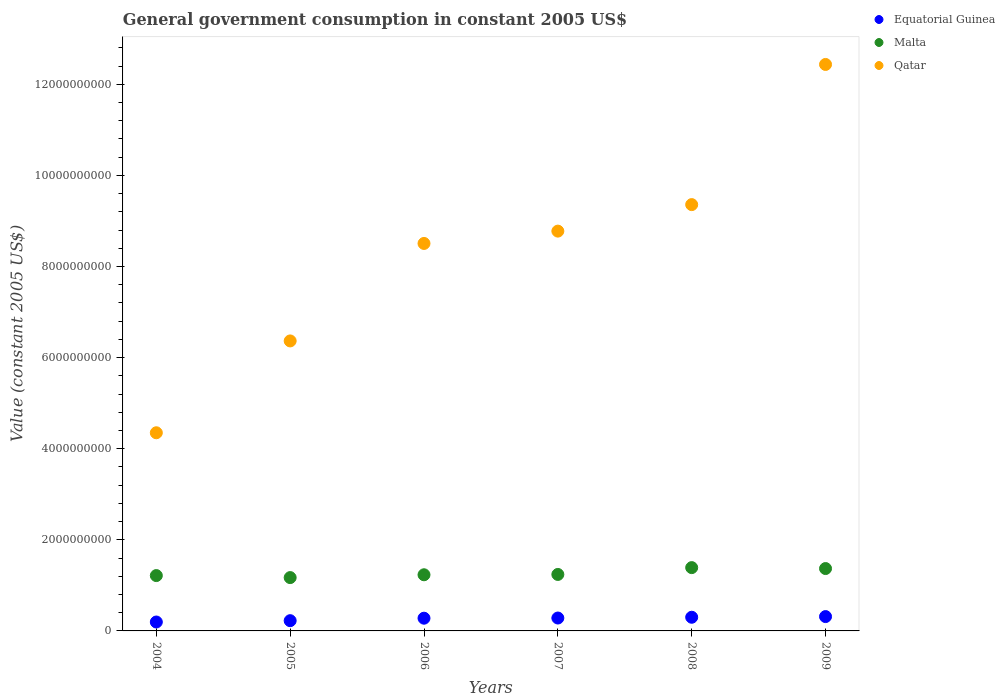How many different coloured dotlines are there?
Keep it short and to the point. 3. Is the number of dotlines equal to the number of legend labels?
Ensure brevity in your answer.  Yes. What is the government conusmption in Equatorial Guinea in 2006?
Ensure brevity in your answer.  2.79e+08. Across all years, what is the maximum government conusmption in Qatar?
Provide a short and direct response. 1.24e+1. Across all years, what is the minimum government conusmption in Qatar?
Give a very brief answer. 4.35e+09. In which year was the government conusmption in Qatar minimum?
Your answer should be compact. 2004. What is the total government conusmption in Equatorial Guinea in the graph?
Offer a terse response. 1.60e+09. What is the difference between the government conusmption in Equatorial Guinea in 2007 and that in 2009?
Your answer should be compact. -3.17e+07. What is the difference between the government conusmption in Equatorial Guinea in 2006 and the government conusmption in Qatar in 2005?
Your answer should be very brief. -6.09e+09. What is the average government conusmption in Qatar per year?
Your answer should be compact. 8.30e+09. In the year 2009, what is the difference between the government conusmption in Malta and government conusmption in Equatorial Guinea?
Ensure brevity in your answer.  1.05e+09. In how many years, is the government conusmption in Qatar greater than 2400000000 US$?
Your answer should be very brief. 6. What is the ratio of the government conusmption in Malta in 2004 to that in 2009?
Keep it short and to the point. 0.89. Is the government conusmption in Malta in 2005 less than that in 2009?
Provide a succinct answer. Yes. What is the difference between the highest and the second highest government conusmption in Equatorial Guinea?
Your answer should be very brief. 1.48e+07. What is the difference between the highest and the lowest government conusmption in Equatorial Guinea?
Your answer should be compact. 1.19e+08. In how many years, is the government conusmption in Equatorial Guinea greater than the average government conusmption in Equatorial Guinea taken over all years?
Ensure brevity in your answer.  4. Is the sum of the government conusmption in Equatorial Guinea in 2004 and 2006 greater than the maximum government conusmption in Qatar across all years?
Offer a very short reply. No. Is it the case that in every year, the sum of the government conusmption in Qatar and government conusmption in Equatorial Guinea  is greater than the government conusmption in Malta?
Provide a short and direct response. Yes. Does the government conusmption in Qatar monotonically increase over the years?
Offer a terse response. Yes. Is the government conusmption in Malta strictly greater than the government conusmption in Qatar over the years?
Give a very brief answer. No. How many years are there in the graph?
Provide a short and direct response. 6. Are the values on the major ticks of Y-axis written in scientific E-notation?
Your response must be concise. No. Does the graph contain grids?
Give a very brief answer. No. How many legend labels are there?
Offer a very short reply. 3. How are the legend labels stacked?
Offer a terse response. Vertical. What is the title of the graph?
Your answer should be very brief. General government consumption in constant 2005 US$. What is the label or title of the Y-axis?
Give a very brief answer. Value (constant 2005 US$). What is the Value (constant 2005 US$) of Equatorial Guinea in 2004?
Ensure brevity in your answer.  1.96e+08. What is the Value (constant 2005 US$) in Malta in 2004?
Give a very brief answer. 1.21e+09. What is the Value (constant 2005 US$) in Qatar in 2004?
Offer a terse response. 4.35e+09. What is the Value (constant 2005 US$) in Equatorial Guinea in 2005?
Ensure brevity in your answer.  2.25e+08. What is the Value (constant 2005 US$) of Malta in 2005?
Provide a succinct answer. 1.17e+09. What is the Value (constant 2005 US$) in Qatar in 2005?
Your answer should be very brief. 6.37e+09. What is the Value (constant 2005 US$) of Equatorial Guinea in 2006?
Ensure brevity in your answer.  2.79e+08. What is the Value (constant 2005 US$) in Malta in 2006?
Provide a succinct answer. 1.23e+09. What is the Value (constant 2005 US$) of Qatar in 2006?
Provide a short and direct response. 8.51e+09. What is the Value (constant 2005 US$) in Equatorial Guinea in 2007?
Offer a terse response. 2.83e+08. What is the Value (constant 2005 US$) of Malta in 2007?
Your answer should be very brief. 1.24e+09. What is the Value (constant 2005 US$) in Qatar in 2007?
Ensure brevity in your answer.  8.78e+09. What is the Value (constant 2005 US$) of Equatorial Guinea in 2008?
Your answer should be very brief. 3.00e+08. What is the Value (constant 2005 US$) in Malta in 2008?
Make the answer very short. 1.39e+09. What is the Value (constant 2005 US$) of Qatar in 2008?
Provide a succinct answer. 9.36e+09. What is the Value (constant 2005 US$) of Equatorial Guinea in 2009?
Give a very brief answer. 3.15e+08. What is the Value (constant 2005 US$) of Malta in 2009?
Your answer should be compact. 1.37e+09. What is the Value (constant 2005 US$) of Qatar in 2009?
Keep it short and to the point. 1.24e+1. Across all years, what is the maximum Value (constant 2005 US$) of Equatorial Guinea?
Keep it short and to the point. 3.15e+08. Across all years, what is the maximum Value (constant 2005 US$) in Malta?
Keep it short and to the point. 1.39e+09. Across all years, what is the maximum Value (constant 2005 US$) of Qatar?
Make the answer very short. 1.24e+1. Across all years, what is the minimum Value (constant 2005 US$) in Equatorial Guinea?
Offer a terse response. 1.96e+08. Across all years, what is the minimum Value (constant 2005 US$) of Malta?
Make the answer very short. 1.17e+09. Across all years, what is the minimum Value (constant 2005 US$) in Qatar?
Your answer should be compact. 4.35e+09. What is the total Value (constant 2005 US$) of Equatorial Guinea in the graph?
Keep it short and to the point. 1.60e+09. What is the total Value (constant 2005 US$) in Malta in the graph?
Offer a terse response. 7.62e+09. What is the total Value (constant 2005 US$) in Qatar in the graph?
Your answer should be compact. 4.98e+1. What is the difference between the Value (constant 2005 US$) in Equatorial Guinea in 2004 and that in 2005?
Ensure brevity in your answer.  -2.92e+07. What is the difference between the Value (constant 2005 US$) of Malta in 2004 and that in 2005?
Your answer should be very brief. 4.41e+07. What is the difference between the Value (constant 2005 US$) in Qatar in 2004 and that in 2005?
Ensure brevity in your answer.  -2.02e+09. What is the difference between the Value (constant 2005 US$) in Equatorial Guinea in 2004 and that in 2006?
Give a very brief answer. -8.36e+07. What is the difference between the Value (constant 2005 US$) in Malta in 2004 and that in 2006?
Ensure brevity in your answer.  -1.77e+07. What is the difference between the Value (constant 2005 US$) in Qatar in 2004 and that in 2006?
Make the answer very short. -4.16e+09. What is the difference between the Value (constant 2005 US$) in Equatorial Guinea in 2004 and that in 2007?
Offer a terse response. -8.74e+07. What is the difference between the Value (constant 2005 US$) in Malta in 2004 and that in 2007?
Provide a succinct answer. -2.49e+07. What is the difference between the Value (constant 2005 US$) in Qatar in 2004 and that in 2007?
Your answer should be compact. -4.43e+09. What is the difference between the Value (constant 2005 US$) in Equatorial Guinea in 2004 and that in 2008?
Your response must be concise. -1.04e+08. What is the difference between the Value (constant 2005 US$) of Malta in 2004 and that in 2008?
Offer a terse response. -1.75e+08. What is the difference between the Value (constant 2005 US$) of Qatar in 2004 and that in 2008?
Your response must be concise. -5.01e+09. What is the difference between the Value (constant 2005 US$) of Equatorial Guinea in 2004 and that in 2009?
Ensure brevity in your answer.  -1.19e+08. What is the difference between the Value (constant 2005 US$) in Malta in 2004 and that in 2009?
Ensure brevity in your answer.  -1.54e+08. What is the difference between the Value (constant 2005 US$) of Qatar in 2004 and that in 2009?
Your response must be concise. -8.09e+09. What is the difference between the Value (constant 2005 US$) of Equatorial Guinea in 2005 and that in 2006?
Ensure brevity in your answer.  -5.44e+07. What is the difference between the Value (constant 2005 US$) in Malta in 2005 and that in 2006?
Give a very brief answer. -6.18e+07. What is the difference between the Value (constant 2005 US$) in Qatar in 2005 and that in 2006?
Your answer should be compact. -2.14e+09. What is the difference between the Value (constant 2005 US$) of Equatorial Guinea in 2005 and that in 2007?
Make the answer very short. -5.83e+07. What is the difference between the Value (constant 2005 US$) of Malta in 2005 and that in 2007?
Keep it short and to the point. -6.90e+07. What is the difference between the Value (constant 2005 US$) of Qatar in 2005 and that in 2007?
Keep it short and to the point. -2.41e+09. What is the difference between the Value (constant 2005 US$) in Equatorial Guinea in 2005 and that in 2008?
Give a very brief answer. -7.52e+07. What is the difference between the Value (constant 2005 US$) in Malta in 2005 and that in 2008?
Make the answer very short. -2.19e+08. What is the difference between the Value (constant 2005 US$) of Qatar in 2005 and that in 2008?
Keep it short and to the point. -2.99e+09. What is the difference between the Value (constant 2005 US$) in Equatorial Guinea in 2005 and that in 2009?
Give a very brief answer. -9.00e+07. What is the difference between the Value (constant 2005 US$) in Malta in 2005 and that in 2009?
Your response must be concise. -1.98e+08. What is the difference between the Value (constant 2005 US$) in Qatar in 2005 and that in 2009?
Offer a terse response. -6.07e+09. What is the difference between the Value (constant 2005 US$) of Equatorial Guinea in 2006 and that in 2007?
Keep it short and to the point. -3.85e+06. What is the difference between the Value (constant 2005 US$) in Malta in 2006 and that in 2007?
Give a very brief answer. -7.18e+06. What is the difference between the Value (constant 2005 US$) in Qatar in 2006 and that in 2007?
Provide a short and direct response. -2.71e+08. What is the difference between the Value (constant 2005 US$) of Equatorial Guinea in 2006 and that in 2008?
Provide a short and direct response. -2.08e+07. What is the difference between the Value (constant 2005 US$) in Malta in 2006 and that in 2008?
Your answer should be compact. -1.57e+08. What is the difference between the Value (constant 2005 US$) of Qatar in 2006 and that in 2008?
Make the answer very short. -8.52e+08. What is the difference between the Value (constant 2005 US$) in Equatorial Guinea in 2006 and that in 2009?
Ensure brevity in your answer.  -3.56e+07. What is the difference between the Value (constant 2005 US$) in Malta in 2006 and that in 2009?
Offer a terse response. -1.37e+08. What is the difference between the Value (constant 2005 US$) of Qatar in 2006 and that in 2009?
Offer a terse response. -3.93e+09. What is the difference between the Value (constant 2005 US$) in Equatorial Guinea in 2007 and that in 2008?
Ensure brevity in your answer.  -1.69e+07. What is the difference between the Value (constant 2005 US$) in Malta in 2007 and that in 2008?
Your response must be concise. -1.50e+08. What is the difference between the Value (constant 2005 US$) of Qatar in 2007 and that in 2008?
Your answer should be very brief. -5.82e+08. What is the difference between the Value (constant 2005 US$) of Equatorial Guinea in 2007 and that in 2009?
Your answer should be very brief. -3.17e+07. What is the difference between the Value (constant 2005 US$) of Malta in 2007 and that in 2009?
Make the answer very short. -1.29e+08. What is the difference between the Value (constant 2005 US$) of Qatar in 2007 and that in 2009?
Ensure brevity in your answer.  -3.66e+09. What is the difference between the Value (constant 2005 US$) of Equatorial Guinea in 2008 and that in 2009?
Your answer should be very brief. -1.48e+07. What is the difference between the Value (constant 2005 US$) in Malta in 2008 and that in 2009?
Keep it short and to the point. 2.03e+07. What is the difference between the Value (constant 2005 US$) in Qatar in 2008 and that in 2009?
Make the answer very short. -3.08e+09. What is the difference between the Value (constant 2005 US$) in Equatorial Guinea in 2004 and the Value (constant 2005 US$) in Malta in 2005?
Your answer should be compact. -9.75e+08. What is the difference between the Value (constant 2005 US$) of Equatorial Guinea in 2004 and the Value (constant 2005 US$) of Qatar in 2005?
Your response must be concise. -6.17e+09. What is the difference between the Value (constant 2005 US$) in Malta in 2004 and the Value (constant 2005 US$) in Qatar in 2005?
Keep it short and to the point. -5.15e+09. What is the difference between the Value (constant 2005 US$) of Equatorial Guinea in 2004 and the Value (constant 2005 US$) of Malta in 2006?
Provide a succinct answer. -1.04e+09. What is the difference between the Value (constant 2005 US$) in Equatorial Guinea in 2004 and the Value (constant 2005 US$) in Qatar in 2006?
Keep it short and to the point. -8.31e+09. What is the difference between the Value (constant 2005 US$) in Malta in 2004 and the Value (constant 2005 US$) in Qatar in 2006?
Your answer should be very brief. -7.29e+09. What is the difference between the Value (constant 2005 US$) in Equatorial Guinea in 2004 and the Value (constant 2005 US$) in Malta in 2007?
Your response must be concise. -1.04e+09. What is the difference between the Value (constant 2005 US$) of Equatorial Guinea in 2004 and the Value (constant 2005 US$) of Qatar in 2007?
Your answer should be compact. -8.58e+09. What is the difference between the Value (constant 2005 US$) in Malta in 2004 and the Value (constant 2005 US$) in Qatar in 2007?
Provide a short and direct response. -7.56e+09. What is the difference between the Value (constant 2005 US$) in Equatorial Guinea in 2004 and the Value (constant 2005 US$) in Malta in 2008?
Provide a succinct answer. -1.19e+09. What is the difference between the Value (constant 2005 US$) in Equatorial Guinea in 2004 and the Value (constant 2005 US$) in Qatar in 2008?
Give a very brief answer. -9.16e+09. What is the difference between the Value (constant 2005 US$) of Malta in 2004 and the Value (constant 2005 US$) of Qatar in 2008?
Your answer should be very brief. -8.14e+09. What is the difference between the Value (constant 2005 US$) of Equatorial Guinea in 2004 and the Value (constant 2005 US$) of Malta in 2009?
Your answer should be very brief. -1.17e+09. What is the difference between the Value (constant 2005 US$) in Equatorial Guinea in 2004 and the Value (constant 2005 US$) in Qatar in 2009?
Provide a short and direct response. -1.22e+1. What is the difference between the Value (constant 2005 US$) of Malta in 2004 and the Value (constant 2005 US$) of Qatar in 2009?
Offer a terse response. -1.12e+1. What is the difference between the Value (constant 2005 US$) in Equatorial Guinea in 2005 and the Value (constant 2005 US$) in Malta in 2006?
Your answer should be very brief. -1.01e+09. What is the difference between the Value (constant 2005 US$) in Equatorial Guinea in 2005 and the Value (constant 2005 US$) in Qatar in 2006?
Make the answer very short. -8.28e+09. What is the difference between the Value (constant 2005 US$) in Malta in 2005 and the Value (constant 2005 US$) in Qatar in 2006?
Keep it short and to the point. -7.33e+09. What is the difference between the Value (constant 2005 US$) in Equatorial Guinea in 2005 and the Value (constant 2005 US$) in Malta in 2007?
Your answer should be very brief. -1.01e+09. What is the difference between the Value (constant 2005 US$) in Equatorial Guinea in 2005 and the Value (constant 2005 US$) in Qatar in 2007?
Offer a terse response. -8.55e+09. What is the difference between the Value (constant 2005 US$) in Malta in 2005 and the Value (constant 2005 US$) in Qatar in 2007?
Give a very brief answer. -7.61e+09. What is the difference between the Value (constant 2005 US$) in Equatorial Guinea in 2005 and the Value (constant 2005 US$) in Malta in 2008?
Offer a terse response. -1.16e+09. What is the difference between the Value (constant 2005 US$) in Equatorial Guinea in 2005 and the Value (constant 2005 US$) in Qatar in 2008?
Your answer should be compact. -9.13e+09. What is the difference between the Value (constant 2005 US$) in Malta in 2005 and the Value (constant 2005 US$) in Qatar in 2008?
Provide a short and direct response. -8.19e+09. What is the difference between the Value (constant 2005 US$) of Equatorial Guinea in 2005 and the Value (constant 2005 US$) of Malta in 2009?
Ensure brevity in your answer.  -1.14e+09. What is the difference between the Value (constant 2005 US$) in Equatorial Guinea in 2005 and the Value (constant 2005 US$) in Qatar in 2009?
Your answer should be compact. -1.22e+1. What is the difference between the Value (constant 2005 US$) of Malta in 2005 and the Value (constant 2005 US$) of Qatar in 2009?
Offer a very short reply. -1.13e+1. What is the difference between the Value (constant 2005 US$) in Equatorial Guinea in 2006 and the Value (constant 2005 US$) in Malta in 2007?
Provide a short and direct response. -9.60e+08. What is the difference between the Value (constant 2005 US$) of Equatorial Guinea in 2006 and the Value (constant 2005 US$) of Qatar in 2007?
Make the answer very short. -8.50e+09. What is the difference between the Value (constant 2005 US$) in Malta in 2006 and the Value (constant 2005 US$) in Qatar in 2007?
Your response must be concise. -7.54e+09. What is the difference between the Value (constant 2005 US$) in Equatorial Guinea in 2006 and the Value (constant 2005 US$) in Malta in 2008?
Keep it short and to the point. -1.11e+09. What is the difference between the Value (constant 2005 US$) of Equatorial Guinea in 2006 and the Value (constant 2005 US$) of Qatar in 2008?
Offer a terse response. -9.08e+09. What is the difference between the Value (constant 2005 US$) of Malta in 2006 and the Value (constant 2005 US$) of Qatar in 2008?
Provide a succinct answer. -8.13e+09. What is the difference between the Value (constant 2005 US$) of Equatorial Guinea in 2006 and the Value (constant 2005 US$) of Malta in 2009?
Make the answer very short. -1.09e+09. What is the difference between the Value (constant 2005 US$) of Equatorial Guinea in 2006 and the Value (constant 2005 US$) of Qatar in 2009?
Your response must be concise. -1.22e+1. What is the difference between the Value (constant 2005 US$) of Malta in 2006 and the Value (constant 2005 US$) of Qatar in 2009?
Give a very brief answer. -1.12e+1. What is the difference between the Value (constant 2005 US$) of Equatorial Guinea in 2007 and the Value (constant 2005 US$) of Malta in 2008?
Your answer should be compact. -1.11e+09. What is the difference between the Value (constant 2005 US$) of Equatorial Guinea in 2007 and the Value (constant 2005 US$) of Qatar in 2008?
Give a very brief answer. -9.08e+09. What is the difference between the Value (constant 2005 US$) in Malta in 2007 and the Value (constant 2005 US$) in Qatar in 2008?
Offer a very short reply. -8.12e+09. What is the difference between the Value (constant 2005 US$) in Equatorial Guinea in 2007 and the Value (constant 2005 US$) in Malta in 2009?
Offer a very short reply. -1.09e+09. What is the difference between the Value (constant 2005 US$) in Equatorial Guinea in 2007 and the Value (constant 2005 US$) in Qatar in 2009?
Your response must be concise. -1.22e+1. What is the difference between the Value (constant 2005 US$) of Malta in 2007 and the Value (constant 2005 US$) of Qatar in 2009?
Your answer should be compact. -1.12e+1. What is the difference between the Value (constant 2005 US$) in Equatorial Guinea in 2008 and the Value (constant 2005 US$) in Malta in 2009?
Your answer should be compact. -1.07e+09. What is the difference between the Value (constant 2005 US$) of Equatorial Guinea in 2008 and the Value (constant 2005 US$) of Qatar in 2009?
Provide a succinct answer. -1.21e+1. What is the difference between the Value (constant 2005 US$) of Malta in 2008 and the Value (constant 2005 US$) of Qatar in 2009?
Make the answer very short. -1.10e+1. What is the average Value (constant 2005 US$) of Equatorial Guinea per year?
Ensure brevity in your answer.  2.66e+08. What is the average Value (constant 2005 US$) in Malta per year?
Provide a short and direct response. 1.27e+09. What is the average Value (constant 2005 US$) of Qatar per year?
Keep it short and to the point. 8.30e+09. In the year 2004, what is the difference between the Value (constant 2005 US$) in Equatorial Guinea and Value (constant 2005 US$) in Malta?
Ensure brevity in your answer.  -1.02e+09. In the year 2004, what is the difference between the Value (constant 2005 US$) in Equatorial Guinea and Value (constant 2005 US$) in Qatar?
Ensure brevity in your answer.  -4.15e+09. In the year 2004, what is the difference between the Value (constant 2005 US$) in Malta and Value (constant 2005 US$) in Qatar?
Ensure brevity in your answer.  -3.13e+09. In the year 2005, what is the difference between the Value (constant 2005 US$) in Equatorial Guinea and Value (constant 2005 US$) in Malta?
Keep it short and to the point. -9.46e+08. In the year 2005, what is the difference between the Value (constant 2005 US$) of Equatorial Guinea and Value (constant 2005 US$) of Qatar?
Provide a succinct answer. -6.14e+09. In the year 2005, what is the difference between the Value (constant 2005 US$) in Malta and Value (constant 2005 US$) in Qatar?
Your answer should be very brief. -5.20e+09. In the year 2006, what is the difference between the Value (constant 2005 US$) in Equatorial Guinea and Value (constant 2005 US$) in Malta?
Make the answer very short. -9.53e+08. In the year 2006, what is the difference between the Value (constant 2005 US$) in Equatorial Guinea and Value (constant 2005 US$) in Qatar?
Offer a terse response. -8.23e+09. In the year 2006, what is the difference between the Value (constant 2005 US$) of Malta and Value (constant 2005 US$) of Qatar?
Provide a succinct answer. -7.27e+09. In the year 2007, what is the difference between the Value (constant 2005 US$) in Equatorial Guinea and Value (constant 2005 US$) in Malta?
Your answer should be compact. -9.57e+08. In the year 2007, what is the difference between the Value (constant 2005 US$) of Equatorial Guinea and Value (constant 2005 US$) of Qatar?
Your response must be concise. -8.49e+09. In the year 2007, what is the difference between the Value (constant 2005 US$) in Malta and Value (constant 2005 US$) in Qatar?
Your response must be concise. -7.54e+09. In the year 2008, what is the difference between the Value (constant 2005 US$) of Equatorial Guinea and Value (constant 2005 US$) of Malta?
Your answer should be compact. -1.09e+09. In the year 2008, what is the difference between the Value (constant 2005 US$) of Equatorial Guinea and Value (constant 2005 US$) of Qatar?
Provide a succinct answer. -9.06e+09. In the year 2008, what is the difference between the Value (constant 2005 US$) in Malta and Value (constant 2005 US$) in Qatar?
Offer a very short reply. -7.97e+09. In the year 2009, what is the difference between the Value (constant 2005 US$) of Equatorial Guinea and Value (constant 2005 US$) of Malta?
Offer a very short reply. -1.05e+09. In the year 2009, what is the difference between the Value (constant 2005 US$) of Equatorial Guinea and Value (constant 2005 US$) of Qatar?
Offer a very short reply. -1.21e+1. In the year 2009, what is the difference between the Value (constant 2005 US$) of Malta and Value (constant 2005 US$) of Qatar?
Your answer should be very brief. -1.11e+1. What is the ratio of the Value (constant 2005 US$) in Equatorial Guinea in 2004 to that in 2005?
Your answer should be compact. 0.87. What is the ratio of the Value (constant 2005 US$) of Malta in 2004 to that in 2005?
Ensure brevity in your answer.  1.04. What is the ratio of the Value (constant 2005 US$) of Qatar in 2004 to that in 2005?
Your response must be concise. 0.68. What is the ratio of the Value (constant 2005 US$) in Equatorial Guinea in 2004 to that in 2006?
Ensure brevity in your answer.  0.7. What is the ratio of the Value (constant 2005 US$) of Malta in 2004 to that in 2006?
Your answer should be very brief. 0.99. What is the ratio of the Value (constant 2005 US$) in Qatar in 2004 to that in 2006?
Offer a terse response. 0.51. What is the ratio of the Value (constant 2005 US$) in Equatorial Guinea in 2004 to that in 2007?
Provide a short and direct response. 0.69. What is the ratio of the Value (constant 2005 US$) in Malta in 2004 to that in 2007?
Give a very brief answer. 0.98. What is the ratio of the Value (constant 2005 US$) in Qatar in 2004 to that in 2007?
Provide a short and direct response. 0.5. What is the ratio of the Value (constant 2005 US$) of Equatorial Guinea in 2004 to that in 2008?
Your answer should be very brief. 0.65. What is the ratio of the Value (constant 2005 US$) in Malta in 2004 to that in 2008?
Your response must be concise. 0.87. What is the ratio of the Value (constant 2005 US$) of Qatar in 2004 to that in 2008?
Your response must be concise. 0.46. What is the ratio of the Value (constant 2005 US$) in Equatorial Guinea in 2004 to that in 2009?
Provide a succinct answer. 0.62. What is the ratio of the Value (constant 2005 US$) of Malta in 2004 to that in 2009?
Make the answer very short. 0.89. What is the ratio of the Value (constant 2005 US$) in Qatar in 2004 to that in 2009?
Your answer should be very brief. 0.35. What is the ratio of the Value (constant 2005 US$) in Equatorial Guinea in 2005 to that in 2006?
Give a very brief answer. 0.81. What is the ratio of the Value (constant 2005 US$) of Malta in 2005 to that in 2006?
Make the answer very short. 0.95. What is the ratio of the Value (constant 2005 US$) in Qatar in 2005 to that in 2006?
Give a very brief answer. 0.75. What is the ratio of the Value (constant 2005 US$) of Equatorial Guinea in 2005 to that in 2007?
Your response must be concise. 0.79. What is the ratio of the Value (constant 2005 US$) in Malta in 2005 to that in 2007?
Make the answer very short. 0.94. What is the ratio of the Value (constant 2005 US$) of Qatar in 2005 to that in 2007?
Your response must be concise. 0.73. What is the ratio of the Value (constant 2005 US$) of Equatorial Guinea in 2005 to that in 2008?
Your answer should be compact. 0.75. What is the ratio of the Value (constant 2005 US$) in Malta in 2005 to that in 2008?
Provide a succinct answer. 0.84. What is the ratio of the Value (constant 2005 US$) in Qatar in 2005 to that in 2008?
Ensure brevity in your answer.  0.68. What is the ratio of the Value (constant 2005 US$) of Equatorial Guinea in 2005 to that in 2009?
Ensure brevity in your answer.  0.71. What is the ratio of the Value (constant 2005 US$) in Malta in 2005 to that in 2009?
Your response must be concise. 0.85. What is the ratio of the Value (constant 2005 US$) of Qatar in 2005 to that in 2009?
Provide a succinct answer. 0.51. What is the ratio of the Value (constant 2005 US$) in Equatorial Guinea in 2006 to that in 2007?
Keep it short and to the point. 0.99. What is the ratio of the Value (constant 2005 US$) of Malta in 2006 to that in 2007?
Offer a terse response. 0.99. What is the ratio of the Value (constant 2005 US$) in Qatar in 2006 to that in 2007?
Your response must be concise. 0.97. What is the ratio of the Value (constant 2005 US$) of Equatorial Guinea in 2006 to that in 2008?
Keep it short and to the point. 0.93. What is the ratio of the Value (constant 2005 US$) in Malta in 2006 to that in 2008?
Provide a short and direct response. 0.89. What is the ratio of the Value (constant 2005 US$) of Qatar in 2006 to that in 2008?
Give a very brief answer. 0.91. What is the ratio of the Value (constant 2005 US$) in Equatorial Guinea in 2006 to that in 2009?
Your response must be concise. 0.89. What is the ratio of the Value (constant 2005 US$) of Malta in 2006 to that in 2009?
Provide a short and direct response. 0.9. What is the ratio of the Value (constant 2005 US$) in Qatar in 2006 to that in 2009?
Keep it short and to the point. 0.68. What is the ratio of the Value (constant 2005 US$) of Equatorial Guinea in 2007 to that in 2008?
Provide a succinct answer. 0.94. What is the ratio of the Value (constant 2005 US$) of Malta in 2007 to that in 2008?
Your answer should be very brief. 0.89. What is the ratio of the Value (constant 2005 US$) of Qatar in 2007 to that in 2008?
Give a very brief answer. 0.94. What is the ratio of the Value (constant 2005 US$) in Equatorial Guinea in 2007 to that in 2009?
Provide a succinct answer. 0.9. What is the ratio of the Value (constant 2005 US$) of Malta in 2007 to that in 2009?
Keep it short and to the point. 0.91. What is the ratio of the Value (constant 2005 US$) in Qatar in 2007 to that in 2009?
Ensure brevity in your answer.  0.71. What is the ratio of the Value (constant 2005 US$) in Equatorial Guinea in 2008 to that in 2009?
Ensure brevity in your answer.  0.95. What is the ratio of the Value (constant 2005 US$) of Malta in 2008 to that in 2009?
Your response must be concise. 1.01. What is the ratio of the Value (constant 2005 US$) of Qatar in 2008 to that in 2009?
Give a very brief answer. 0.75. What is the difference between the highest and the second highest Value (constant 2005 US$) in Equatorial Guinea?
Your answer should be very brief. 1.48e+07. What is the difference between the highest and the second highest Value (constant 2005 US$) in Malta?
Your answer should be compact. 2.03e+07. What is the difference between the highest and the second highest Value (constant 2005 US$) of Qatar?
Give a very brief answer. 3.08e+09. What is the difference between the highest and the lowest Value (constant 2005 US$) in Equatorial Guinea?
Provide a short and direct response. 1.19e+08. What is the difference between the highest and the lowest Value (constant 2005 US$) in Malta?
Keep it short and to the point. 2.19e+08. What is the difference between the highest and the lowest Value (constant 2005 US$) of Qatar?
Keep it short and to the point. 8.09e+09. 